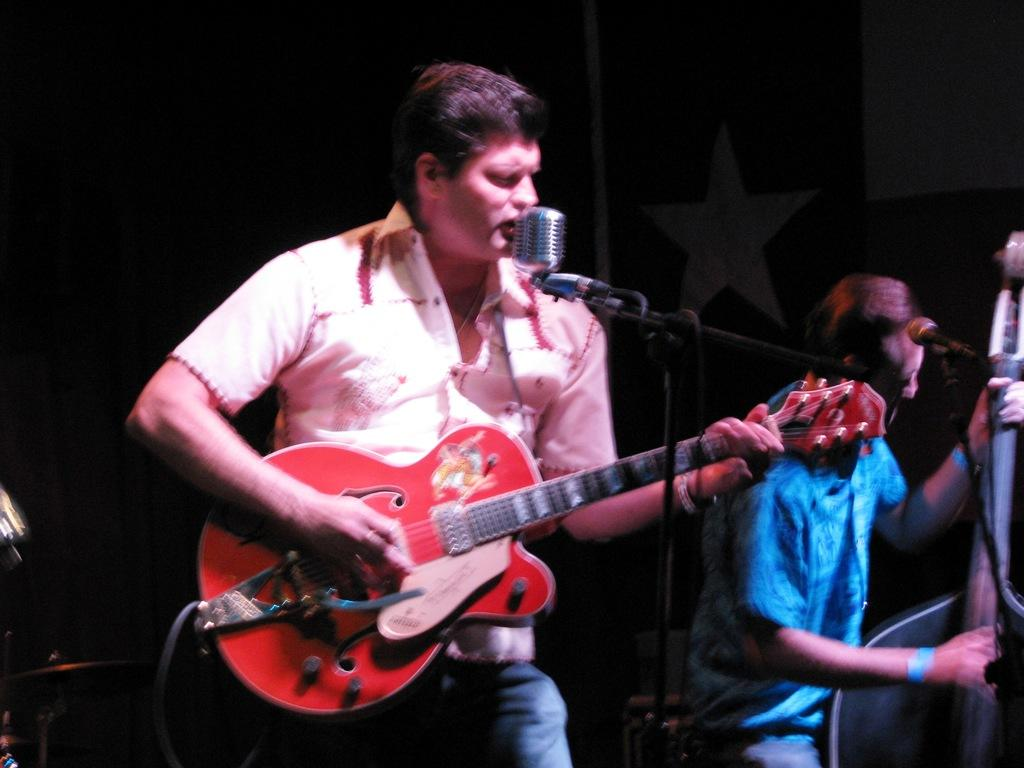What is the man in the image doing? The man is standing, holding a guitar, and singing into a microphone. Can you describe the other person in the image? The other person is playing a musical instrument. What is the man holding in the image? The man is holding a guitar. What is the man using to amplify his voice in the image? The man is singing into a microphone. What type of potato is the man holding in the image? There is no potato present in the image; the man is holding a guitar. 